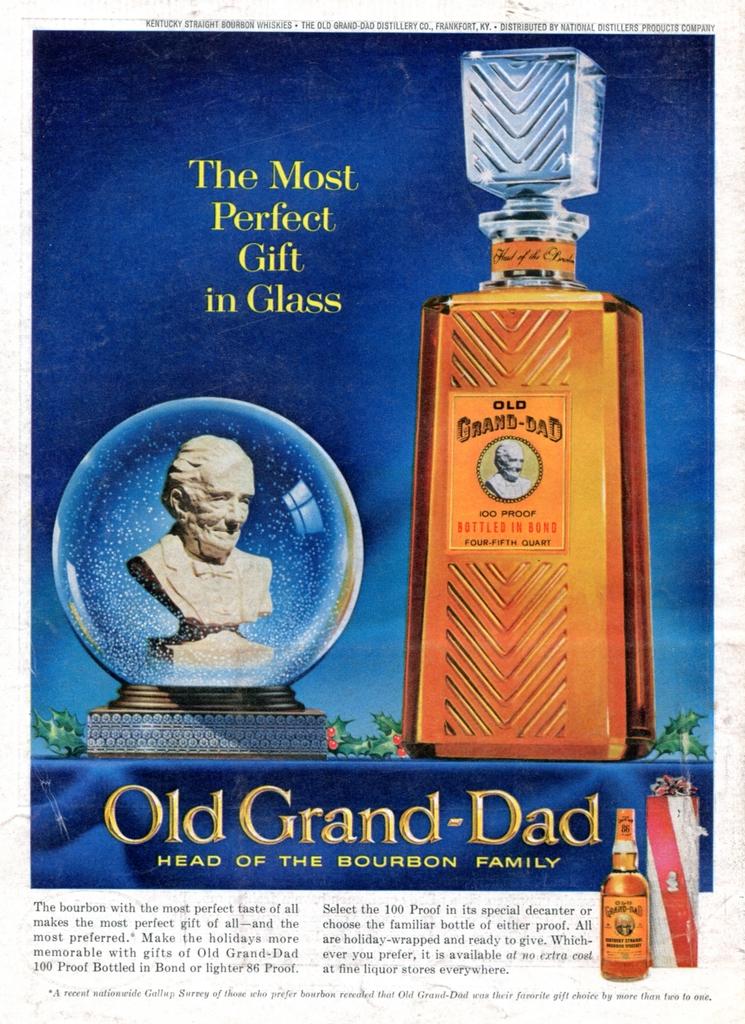What is the brand name of the liquor in the image?
Make the answer very short. Old grand-dad. What type of liquor is this?
Give a very brief answer. Bourbon. 